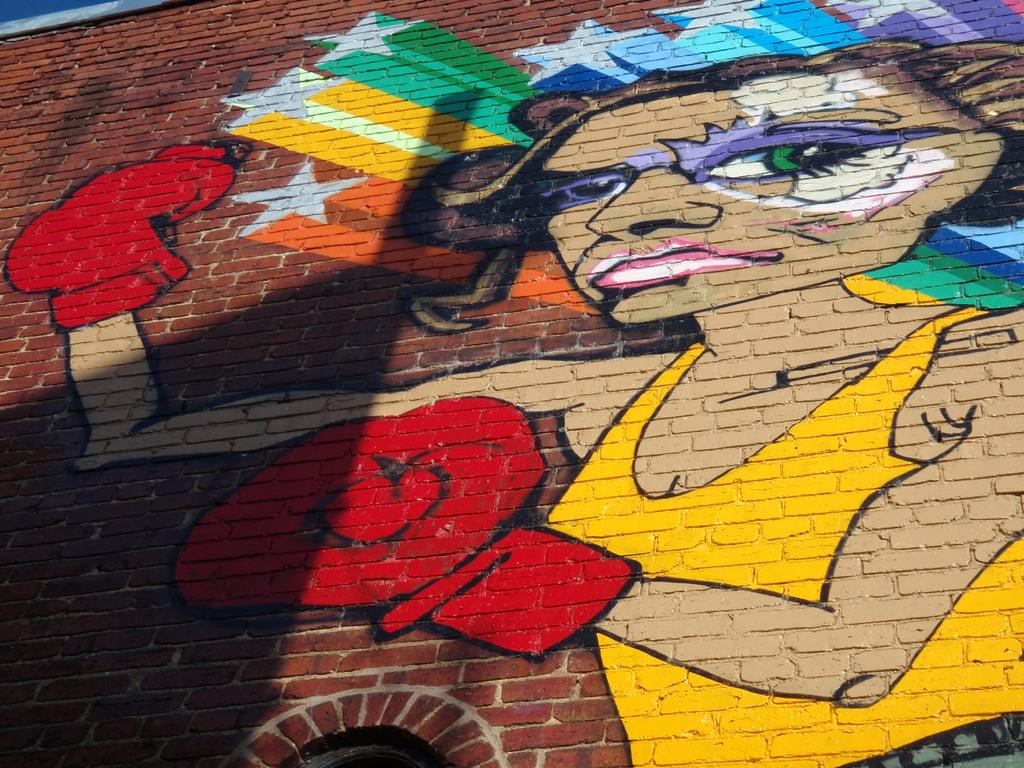What is the main subject of the painting in the image? The painting depicts a woman. What is the woman doing in the painting? The woman is wearing boxing gloves in the painting. Where is the painting located in the image? The painting is on a brick wall. Can you see a kite in the painting? There is no kite present in the painting; it depicts a woman wearing boxing gloves. 